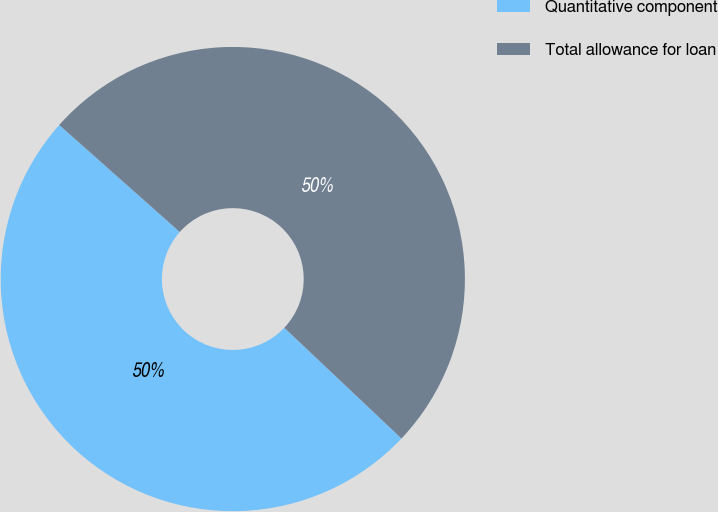Convert chart. <chart><loc_0><loc_0><loc_500><loc_500><pie_chart><fcel>Quantitative component<fcel>Total allowance for loan<nl><fcel>49.5%<fcel>50.5%<nl></chart> 